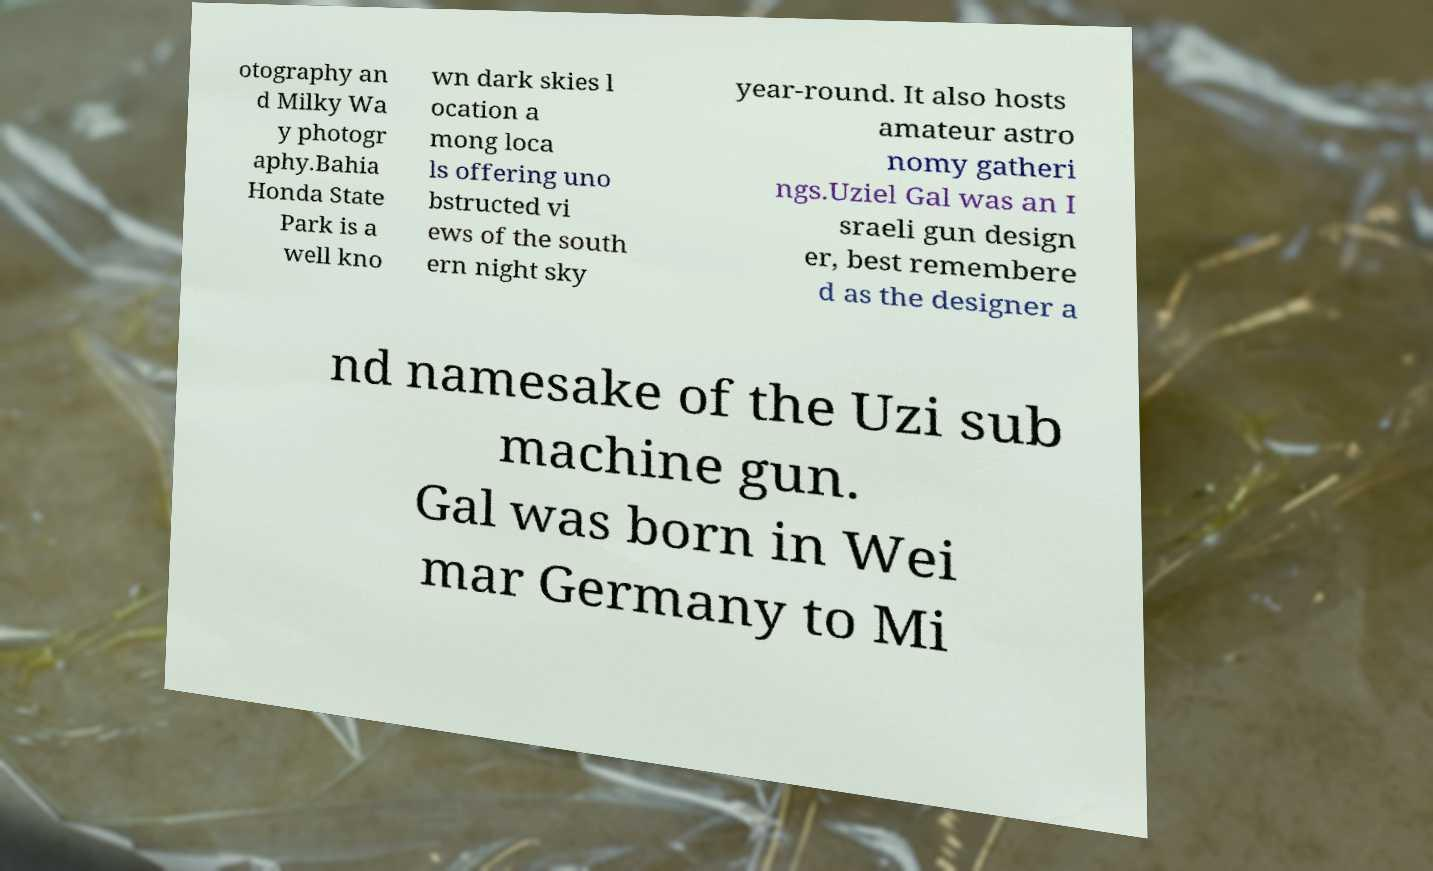What messages or text are displayed in this image? I need them in a readable, typed format. otography an d Milky Wa y photogr aphy.Bahia Honda State Park is a well kno wn dark skies l ocation a mong loca ls offering uno bstructed vi ews of the south ern night sky year-round. It also hosts amateur astro nomy gatheri ngs.Uziel Gal was an I sraeli gun design er, best remembere d as the designer a nd namesake of the Uzi sub machine gun. Gal was born in Wei mar Germany to Mi 